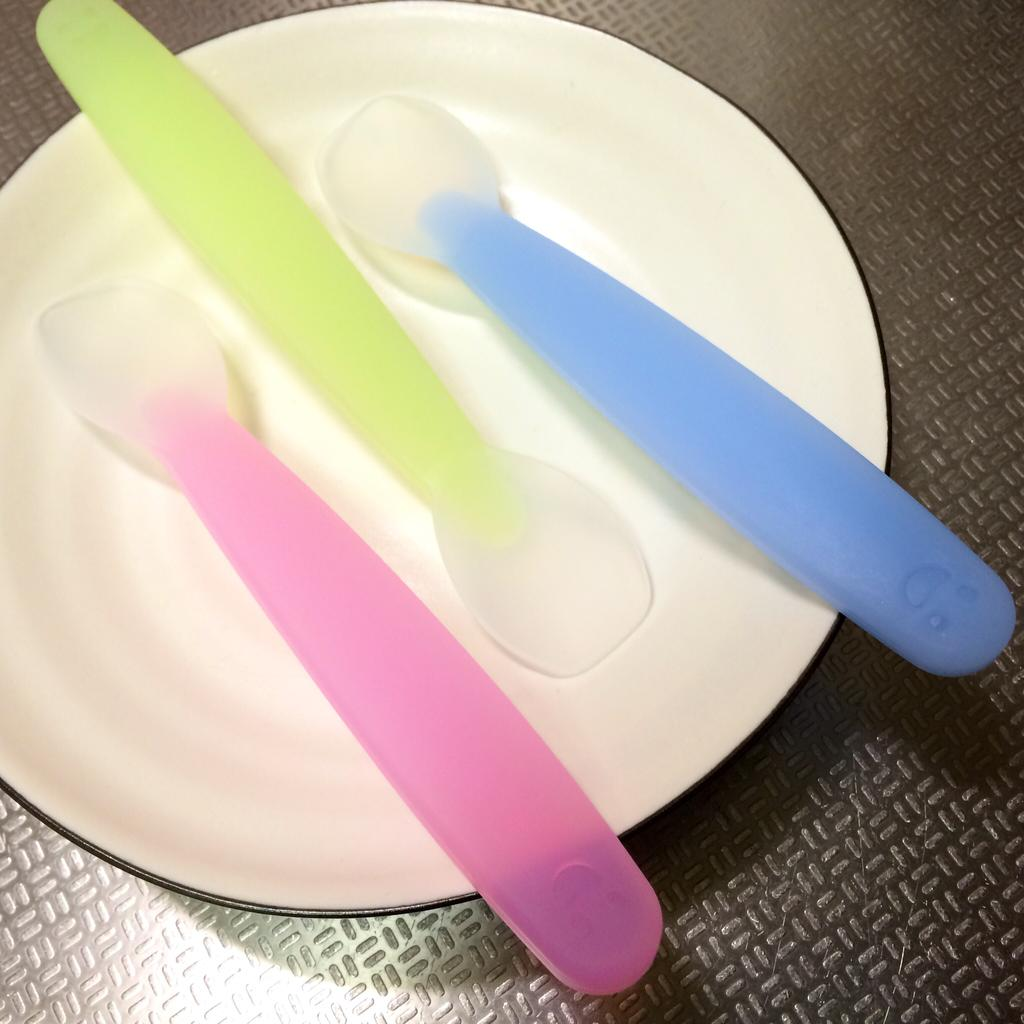How many spoons are visible in the image? There are three spoons in the image. Where are the spoons located? The spoons are placed on a plate. What surface is the plate resting on? The plate is on a table. What is the plot of the story being told by the spoons in the image? There is no story being told by the spoons in the image, as they are simply utensils placed on a plate. 